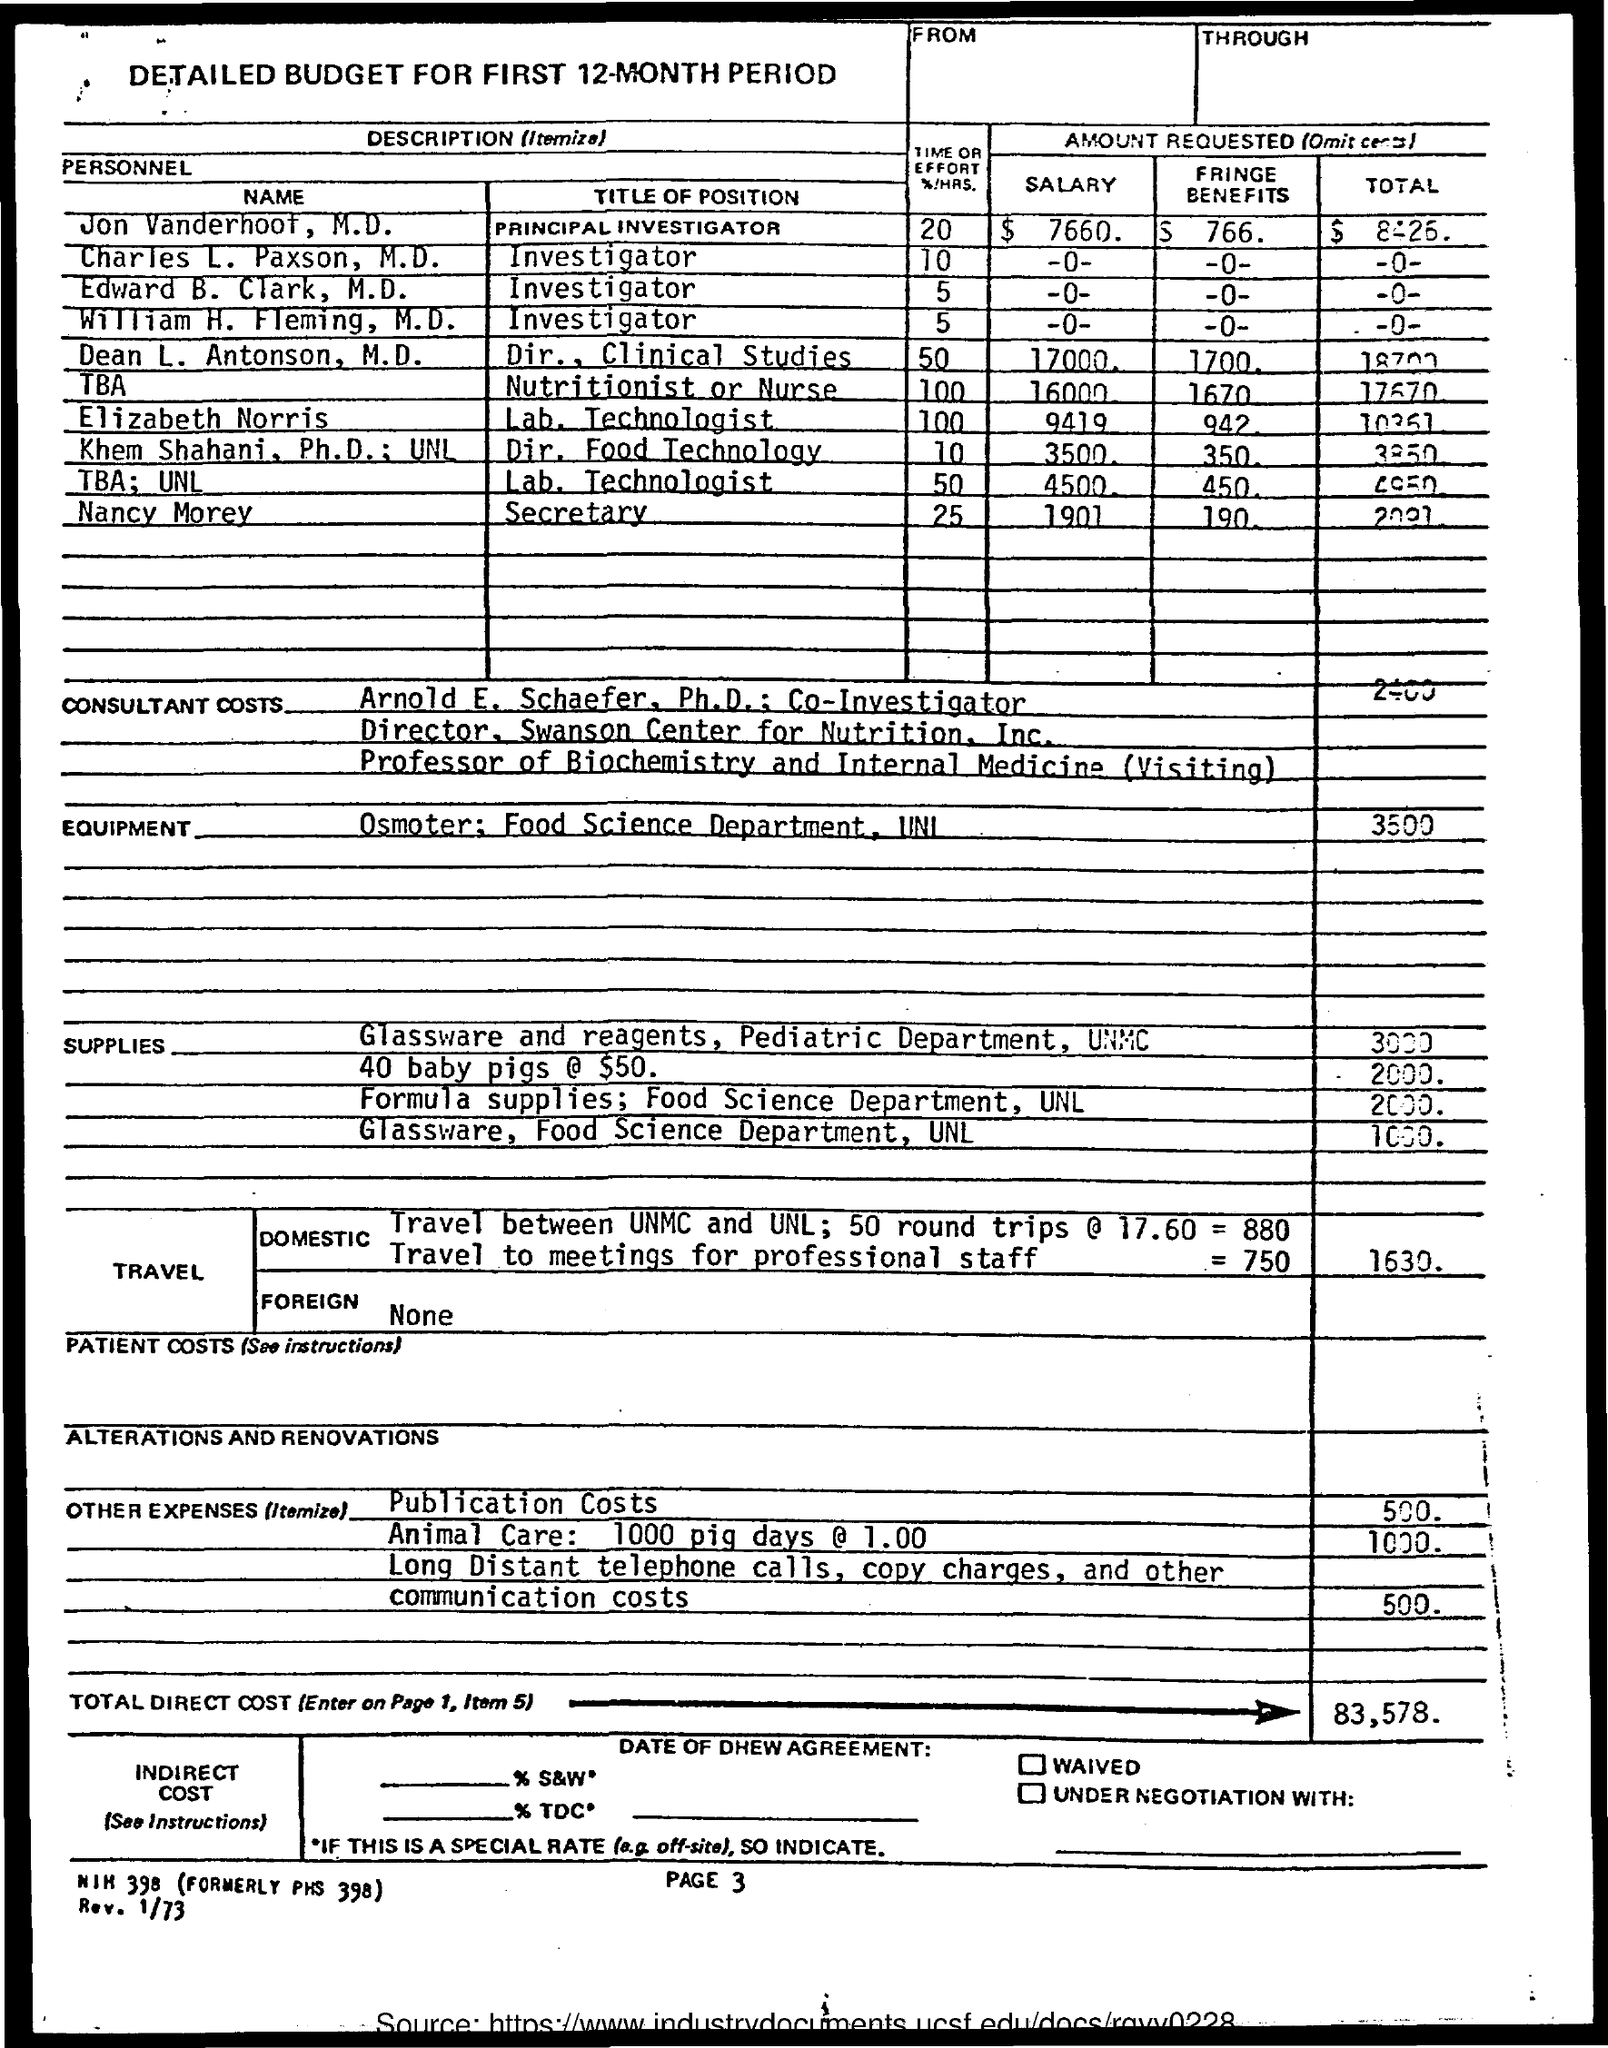What is the title of position for jon vanderhoof ?
Make the answer very short. Principal investigator. What is the title of position for charles l. paxson ?
Keep it short and to the point. Investigator. What is the amount of salary requested by jon vanderhoof ?
Your response must be concise. $ 7660. What is the amount of fringe benefits mentioned for jon vanferhoof ?
Provide a succinct answer. $ 766. What is the title of position given for nancy morey ?
Provide a short and direct response. Secretary. What is the title of position mentioned for elizabeth norris ?
Make the answer very short. Lab. technologist. What is the total direct cost mentioned in the given page ?
Ensure brevity in your answer.  83,578. What is the amount mentioned for publication costs ?
Ensure brevity in your answer.  500. What is the amount mentioned for communication costs ?
Your response must be concise. 500. 